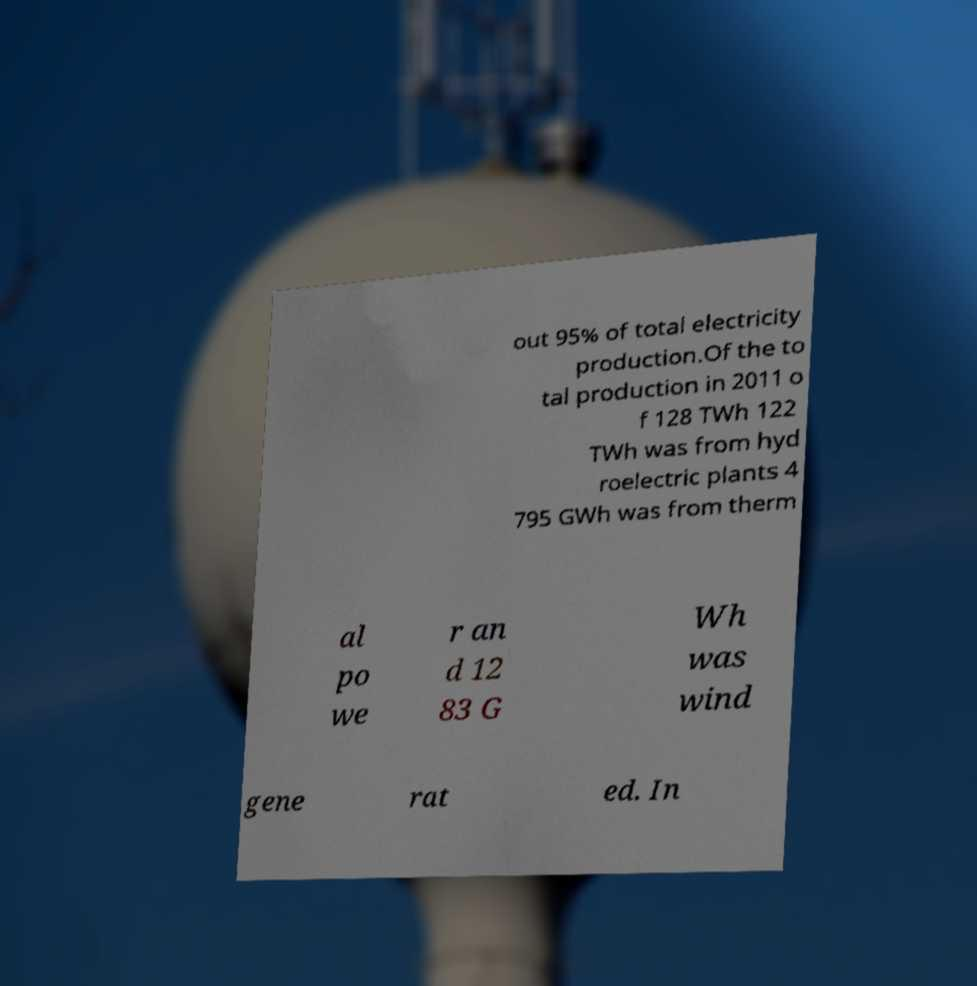There's text embedded in this image that I need extracted. Can you transcribe it verbatim? out 95% of total electricity production.Of the to tal production in 2011 o f 128 TWh 122 TWh was from hyd roelectric plants 4 795 GWh was from therm al po we r an d 12 83 G Wh was wind gene rat ed. In 